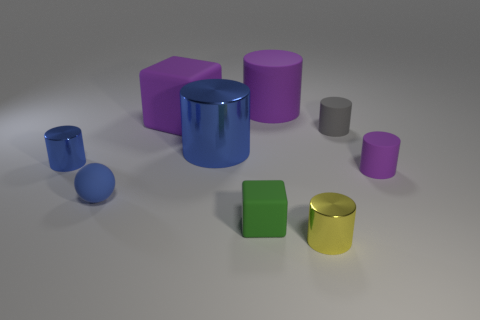How many purple cylinders must be subtracted to get 1 purple cylinders? 1 Subtract all yellow cylinders. How many cylinders are left? 5 Subtract all small yellow cylinders. How many cylinders are left? 5 Subtract 3 cylinders. How many cylinders are left? 3 Subtract all yellow cylinders. Subtract all yellow blocks. How many cylinders are left? 5 Add 1 tiny purple cylinders. How many objects exist? 10 Subtract all cylinders. How many objects are left? 3 Subtract all large blue objects. Subtract all yellow cylinders. How many objects are left? 7 Add 6 matte blocks. How many matte blocks are left? 8 Add 8 big rubber cubes. How many big rubber cubes exist? 9 